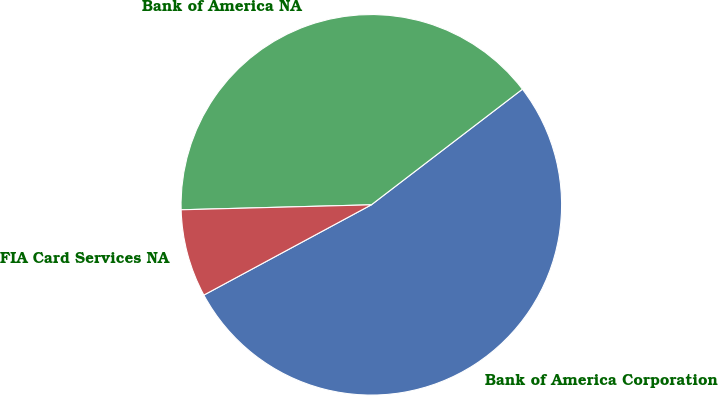Convert chart. <chart><loc_0><loc_0><loc_500><loc_500><pie_chart><fcel>Bank of America Corporation<fcel>Bank of America NA<fcel>FIA Card Services NA<nl><fcel>52.53%<fcel>40.02%<fcel>7.45%<nl></chart> 